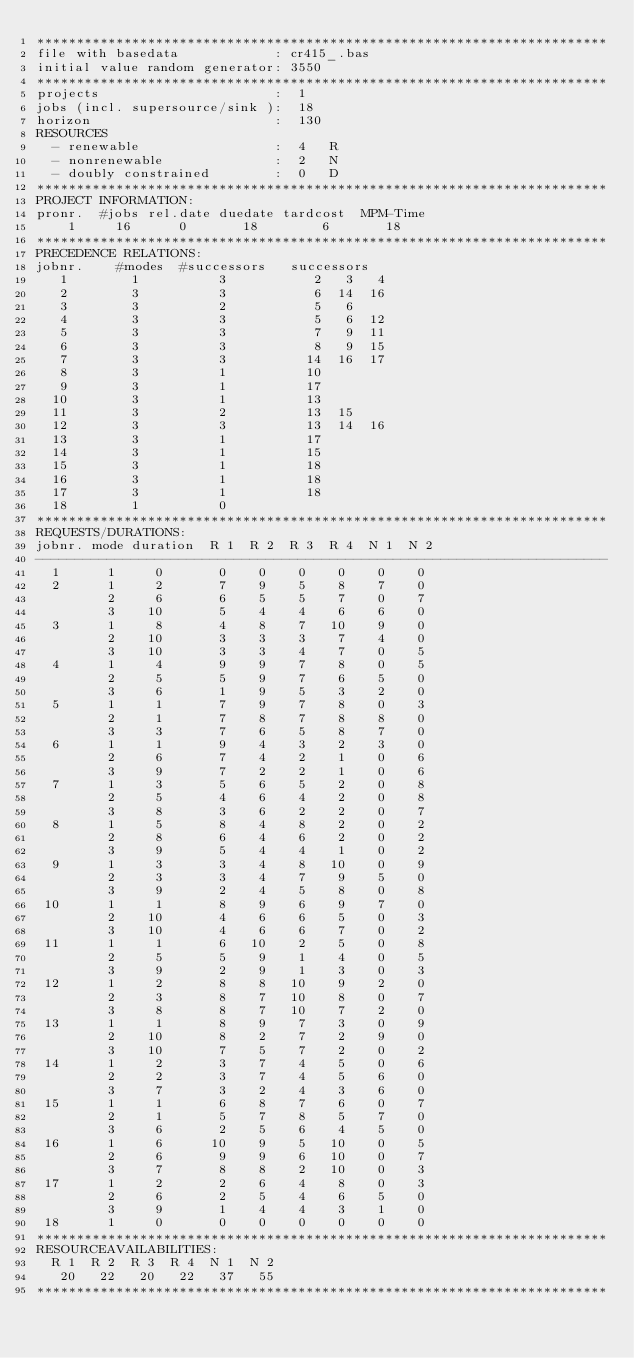<code> <loc_0><loc_0><loc_500><loc_500><_ObjectiveC_>************************************************************************
file with basedata            : cr415_.bas
initial value random generator: 3550
************************************************************************
projects                      :  1
jobs (incl. supersource/sink ):  18
horizon                       :  130
RESOURCES
  - renewable                 :  4   R
  - nonrenewable              :  2   N
  - doubly constrained        :  0   D
************************************************************************
PROJECT INFORMATION:
pronr.  #jobs rel.date duedate tardcost  MPM-Time
    1     16      0       18        6       18
************************************************************************
PRECEDENCE RELATIONS:
jobnr.    #modes  #successors   successors
   1        1          3           2   3   4
   2        3          3           6  14  16
   3        3          2           5   6
   4        3          3           5   6  12
   5        3          3           7   9  11
   6        3          3           8   9  15
   7        3          3          14  16  17
   8        3          1          10
   9        3          1          17
  10        3          1          13
  11        3          2          13  15
  12        3          3          13  14  16
  13        3          1          17
  14        3          1          15
  15        3          1          18
  16        3          1          18
  17        3          1          18
  18        1          0        
************************************************************************
REQUESTS/DURATIONS:
jobnr. mode duration  R 1  R 2  R 3  R 4  N 1  N 2
------------------------------------------------------------------------
  1      1     0       0    0    0    0    0    0
  2      1     2       7    9    5    8    7    0
         2     6       6    5    5    7    0    7
         3    10       5    4    4    6    6    0
  3      1     8       4    8    7   10    9    0
         2    10       3    3    3    7    4    0
         3    10       3    3    4    7    0    5
  4      1     4       9    9    7    8    0    5
         2     5       5    9    7    6    5    0
         3     6       1    9    5    3    2    0
  5      1     1       7    9    7    8    0    3
         2     1       7    8    7    8    8    0
         3     3       7    6    5    8    7    0
  6      1     1       9    4    3    2    3    0
         2     6       7    4    2    1    0    6
         3     9       7    2    2    1    0    6
  7      1     3       5    6    5    2    0    8
         2     5       4    6    4    2    0    8
         3     8       3    6    2    2    0    7
  8      1     5       8    4    8    2    0    2
         2     8       6    4    6    2    0    2
         3     9       5    4    4    1    0    2
  9      1     3       3    4    8   10    0    9
         2     3       3    4    7    9    5    0
         3     9       2    4    5    8    0    8
 10      1     1       8    9    6    9    7    0
         2    10       4    6    6    5    0    3
         3    10       4    6    6    7    0    2
 11      1     1       6   10    2    5    0    8
         2     5       5    9    1    4    0    5
         3     9       2    9    1    3    0    3
 12      1     2       8    8   10    9    2    0
         2     3       8    7   10    8    0    7
         3     8       8    7   10    7    2    0
 13      1     1       8    9    7    3    0    9
         2    10       8    2    7    2    9    0
         3    10       7    5    7    2    0    2
 14      1     2       3    7    4    5    0    6
         2     2       3    7    4    5    6    0
         3     7       3    2    4    3    6    0
 15      1     1       6    8    7    6    0    7
         2     1       5    7    8    5    7    0
         3     6       2    5    6    4    5    0
 16      1     6      10    9    5   10    0    5
         2     6       9    9    6   10    0    7
         3     7       8    8    2   10    0    3
 17      1     2       2    6    4    8    0    3
         2     6       2    5    4    6    5    0
         3     9       1    4    4    3    1    0
 18      1     0       0    0    0    0    0    0
************************************************************************
RESOURCEAVAILABILITIES:
  R 1  R 2  R 3  R 4  N 1  N 2
   20   22   20   22   37   55
************************************************************************
</code> 